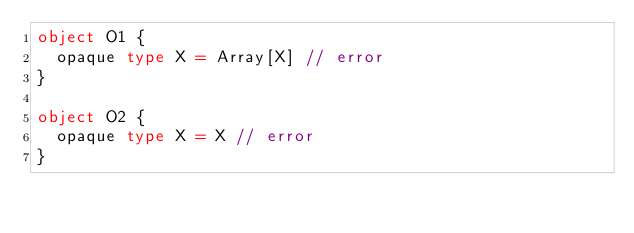Convert code to text. <code><loc_0><loc_0><loc_500><loc_500><_Scala_>object O1 {
  opaque type X = Array[X] // error
}

object O2 {
  opaque type X = X // error
}
</code> 